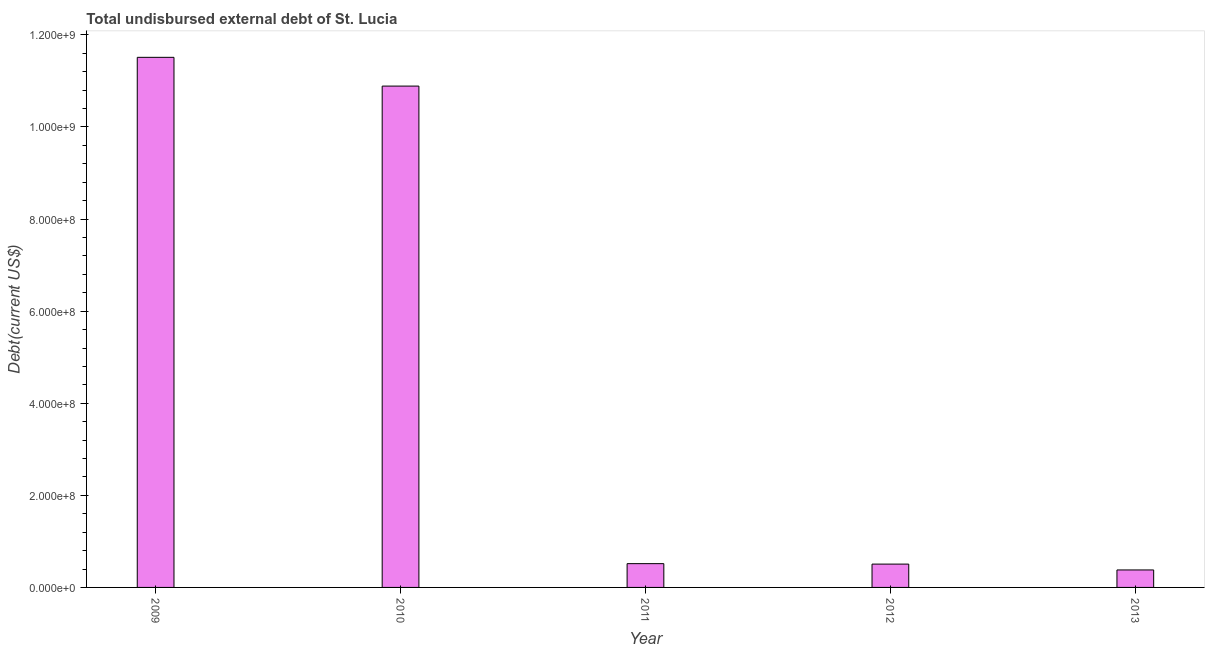Does the graph contain any zero values?
Ensure brevity in your answer.  No. Does the graph contain grids?
Provide a short and direct response. No. What is the title of the graph?
Offer a very short reply. Total undisbursed external debt of St. Lucia. What is the label or title of the X-axis?
Your answer should be very brief. Year. What is the label or title of the Y-axis?
Your response must be concise. Debt(current US$). What is the total debt in 2010?
Make the answer very short. 1.09e+09. Across all years, what is the maximum total debt?
Provide a short and direct response. 1.15e+09. Across all years, what is the minimum total debt?
Ensure brevity in your answer.  3.80e+07. In which year was the total debt maximum?
Keep it short and to the point. 2009. What is the sum of the total debt?
Your response must be concise. 2.38e+09. What is the difference between the total debt in 2009 and 2013?
Ensure brevity in your answer.  1.11e+09. What is the average total debt per year?
Make the answer very short. 4.76e+08. What is the median total debt?
Offer a very short reply. 5.16e+07. What is the ratio of the total debt in 2009 to that in 2012?
Provide a succinct answer. 22.73. Is the total debt in 2009 less than that in 2013?
Give a very brief answer. No. Is the difference between the total debt in 2009 and 2012 greater than the difference between any two years?
Provide a succinct answer. No. What is the difference between the highest and the second highest total debt?
Provide a short and direct response. 6.24e+07. Is the sum of the total debt in 2009 and 2013 greater than the maximum total debt across all years?
Provide a succinct answer. Yes. What is the difference between the highest and the lowest total debt?
Provide a short and direct response. 1.11e+09. How many years are there in the graph?
Offer a terse response. 5. Are the values on the major ticks of Y-axis written in scientific E-notation?
Provide a succinct answer. Yes. What is the Debt(current US$) in 2009?
Keep it short and to the point. 1.15e+09. What is the Debt(current US$) of 2010?
Provide a succinct answer. 1.09e+09. What is the Debt(current US$) in 2011?
Your answer should be very brief. 5.16e+07. What is the Debt(current US$) in 2012?
Offer a terse response. 5.07e+07. What is the Debt(current US$) of 2013?
Provide a short and direct response. 3.80e+07. What is the difference between the Debt(current US$) in 2009 and 2010?
Keep it short and to the point. 6.24e+07. What is the difference between the Debt(current US$) in 2009 and 2011?
Give a very brief answer. 1.10e+09. What is the difference between the Debt(current US$) in 2009 and 2012?
Ensure brevity in your answer.  1.10e+09. What is the difference between the Debt(current US$) in 2009 and 2013?
Ensure brevity in your answer.  1.11e+09. What is the difference between the Debt(current US$) in 2010 and 2011?
Keep it short and to the point. 1.04e+09. What is the difference between the Debt(current US$) in 2010 and 2012?
Provide a short and direct response. 1.04e+09. What is the difference between the Debt(current US$) in 2010 and 2013?
Keep it short and to the point. 1.05e+09. What is the difference between the Debt(current US$) in 2011 and 2012?
Provide a succinct answer. 9.88e+05. What is the difference between the Debt(current US$) in 2011 and 2013?
Offer a terse response. 1.37e+07. What is the difference between the Debt(current US$) in 2012 and 2013?
Offer a very short reply. 1.27e+07. What is the ratio of the Debt(current US$) in 2009 to that in 2010?
Your answer should be very brief. 1.06. What is the ratio of the Debt(current US$) in 2009 to that in 2011?
Ensure brevity in your answer.  22.29. What is the ratio of the Debt(current US$) in 2009 to that in 2012?
Make the answer very short. 22.73. What is the ratio of the Debt(current US$) in 2009 to that in 2013?
Give a very brief answer. 30.31. What is the ratio of the Debt(current US$) in 2010 to that in 2011?
Keep it short and to the point. 21.08. What is the ratio of the Debt(current US$) in 2010 to that in 2012?
Make the answer very short. 21.49. What is the ratio of the Debt(current US$) in 2010 to that in 2013?
Ensure brevity in your answer.  28.67. What is the ratio of the Debt(current US$) in 2011 to that in 2012?
Provide a succinct answer. 1.02. What is the ratio of the Debt(current US$) in 2011 to that in 2013?
Provide a short and direct response. 1.36. What is the ratio of the Debt(current US$) in 2012 to that in 2013?
Your response must be concise. 1.33. 